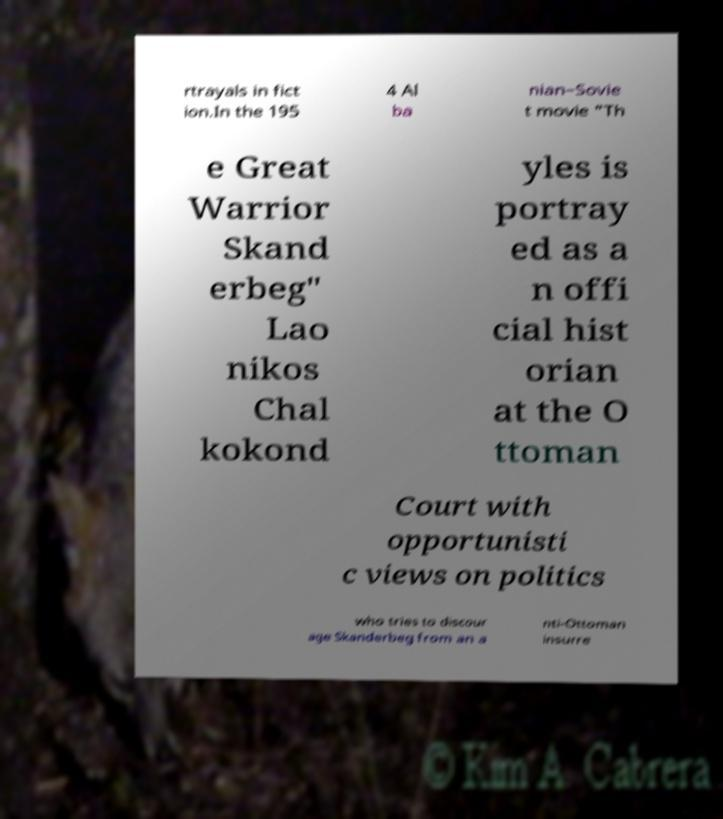For documentation purposes, I need the text within this image transcribed. Could you provide that? rtrayals in fict ion.In the 195 4 Al ba nian–Sovie t movie "Th e Great Warrior Skand erbeg" Lao nikos Chal kokond yles is portray ed as a n offi cial hist orian at the O ttoman Court with opportunisti c views on politics who tries to discour age Skanderbeg from an a nti-Ottoman insurre 